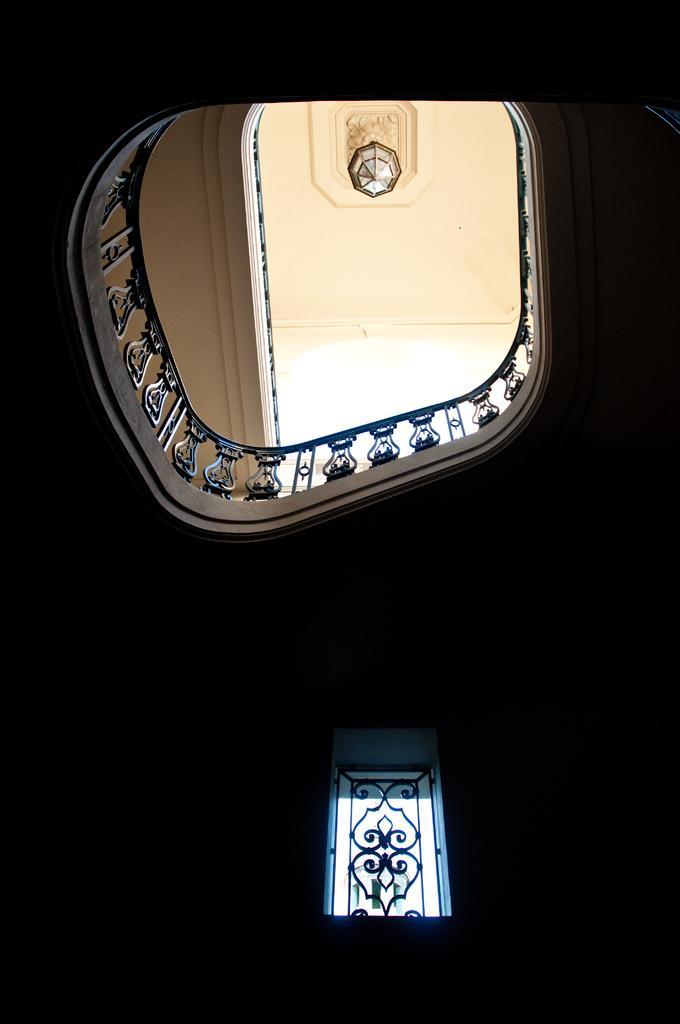Can you describe this image briefly? In this image we can see window, railing and roof. One chandelier is attached to the roof. 